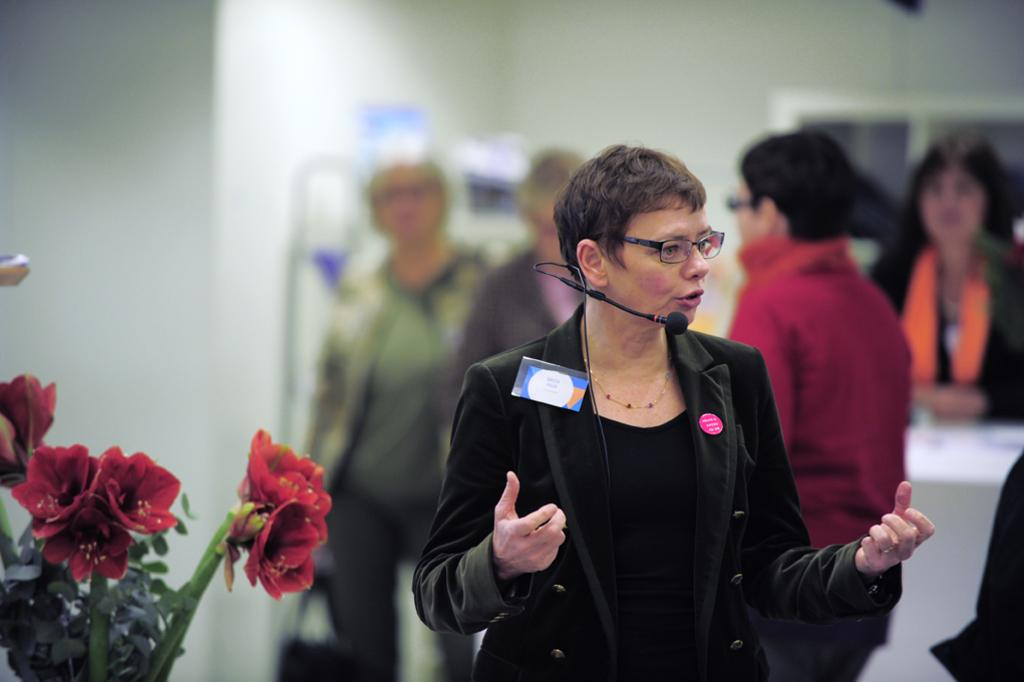Who is the main subject in the image? There is a woman in the middle of the image. What is the woman doing in the image? The woman is speaking into a microphone. What can be seen on the left side of the image? There are flowers on the left side of the image. What is visible in the background of the image? There are people in the background of the image. What type of note is the woman singing in the image? The image does not show the woman singing, only speaking into a microphone. What kind of produce is being harvested in the image? There is no produce or harvesting activity depicted in the image. 